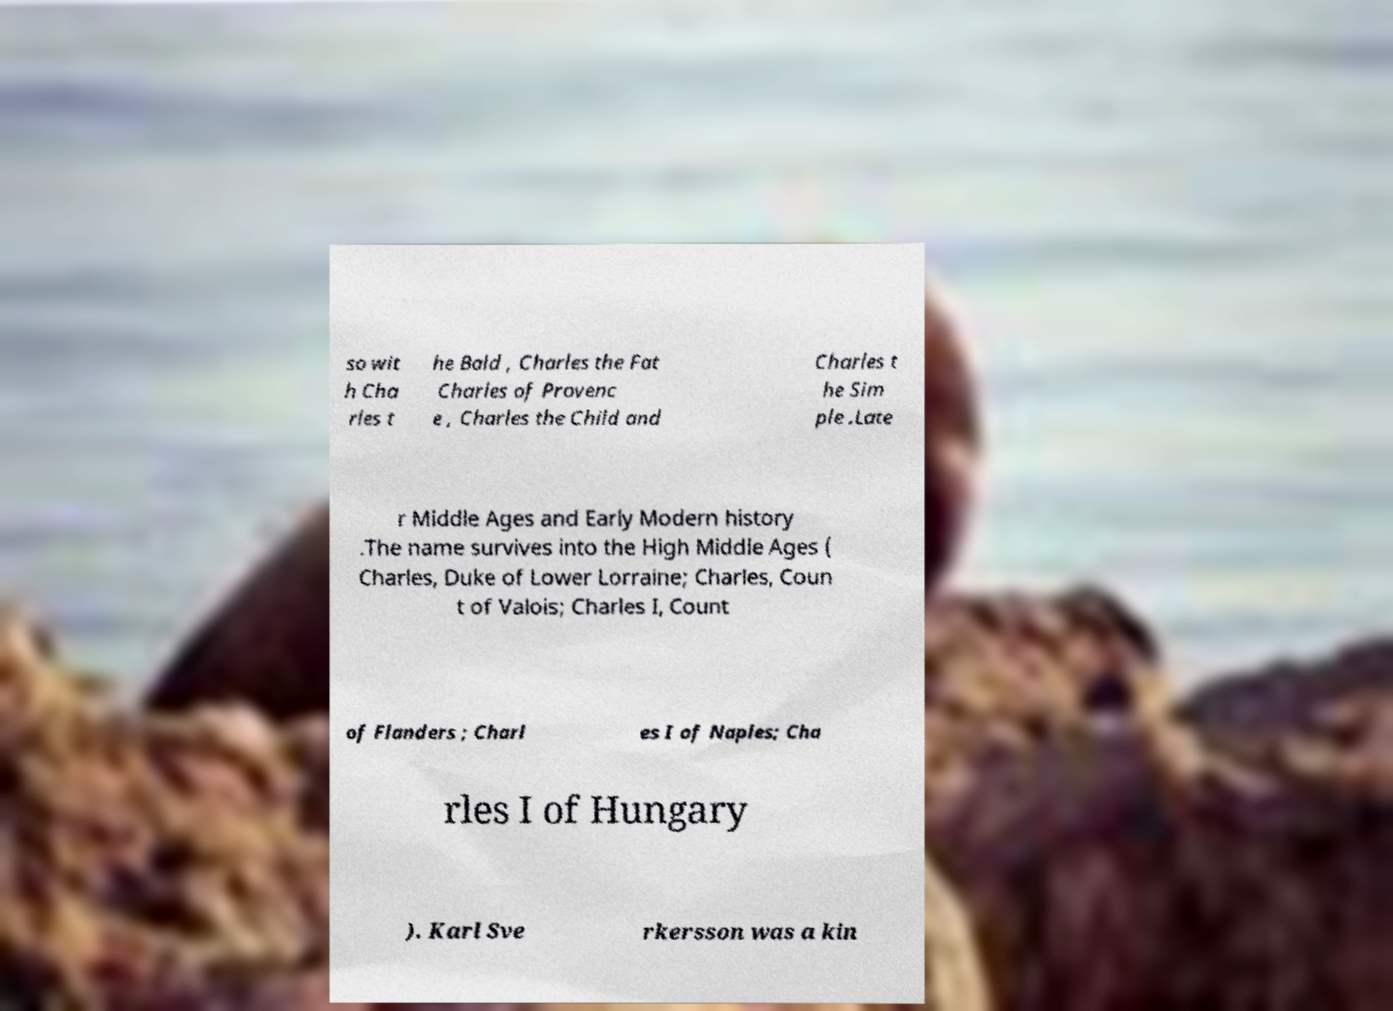Can you accurately transcribe the text from the provided image for me? so wit h Cha rles t he Bald , Charles the Fat Charles of Provenc e , Charles the Child and Charles t he Sim ple .Late r Middle Ages and Early Modern history .The name survives into the High Middle Ages ( Charles, Duke of Lower Lorraine; Charles, Coun t of Valois; Charles I, Count of Flanders ; Charl es I of Naples; Cha rles I of Hungary ). Karl Sve rkersson was a kin 